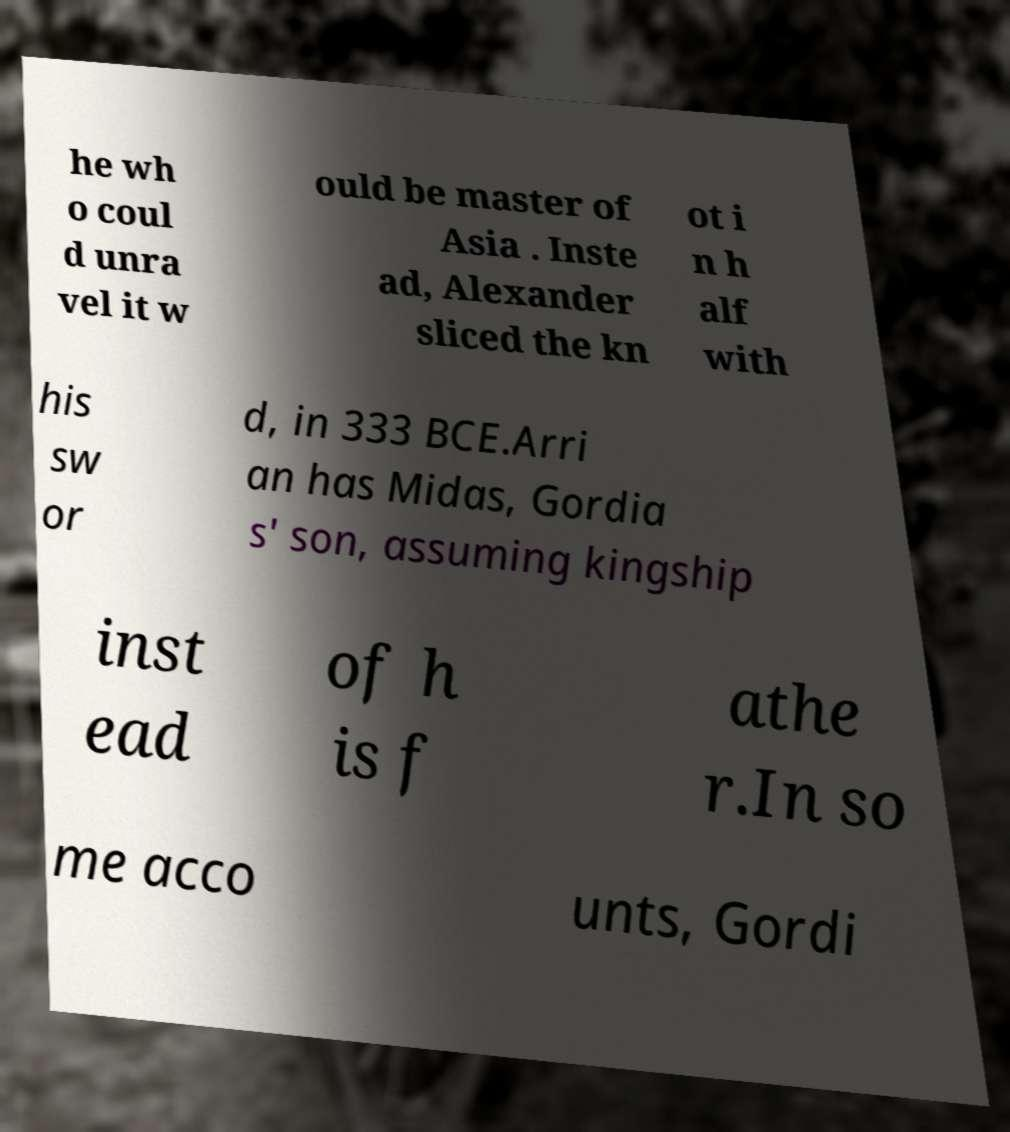For documentation purposes, I need the text within this image transcribed. Could you provide that? he wh o coul d unra vel it w ould be master of Asia . Inste ad, Alexander sliced the kn ot i n h alf with his sw or d, in 333 BCE.Arri an has Midas, Gordia s' son, assuming kingship inst ead of h is f athe r.In so me acco unts, Gordi 